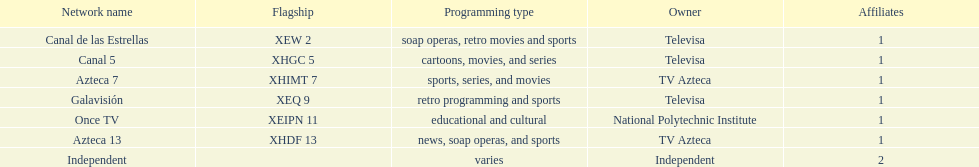Who is the exclusive network owner presented in a continuous order in the chart? Televisa. 